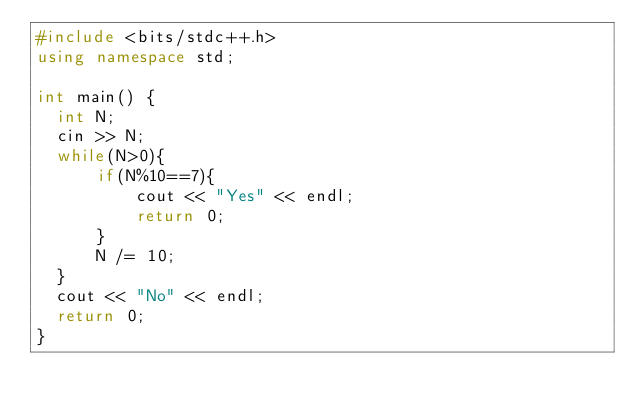Convert code to text. <code><loc_0><loc_0><loc_500><loc_500><_C++_>#include <bits/stdc++.h>
using namespace std;

int main() {
	int N;
	cin >> N;
	while(N>0){
	    if(N%10==7){
	        cout << "Yes" << endl;
	        return 0;
	    }
	    N /= 10;
	}
	cout << "No" << endl;
	return 0;
}</code> 